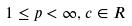Convert formula to latex. <formula><loc_0><loc_0><loc_500><loc_500>1 \leq p < \infty , c \in R</formula> 